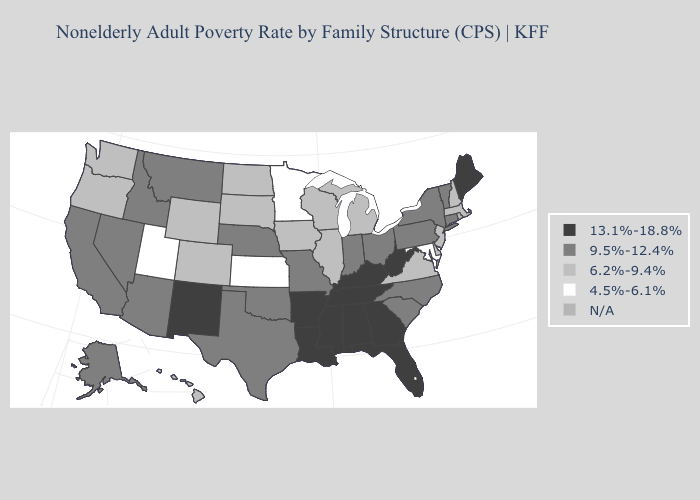Among the states that border Wisconsin , which have the lowest value?
Write a very short answer. Minnesota. Name the states that have a value in the range 13.1%-18.8%?
Answer briefly. Alabama, Arkansas, Florida, Georgia, Kentucky, Louisiana, Maine, Mississippi, New Mexico, Tennessee, West Virginia. Among the states that border Nevada , does California have the lowest value?
Keep it brief. No. Which states have the lowest value in the USA?
Concise answer only. Kansas, Maryland, Minnesota, Utah. Does Pennsylvania have the lowest value in the Northeast?
Concise answer only. No. Among the states that border Colorado , does New Mexico have the highest value?
Short answer required. Yes. What is the lowest value in the USA?
Give a very brief answer. 4.5%-6.1%. Among the states that border Illinois , does Wisconsin have the lowest value?
Keep it brief. Yes. Which states have the lowest value in the MidWest?
Write a very short answer. Kansas, Minnesota. Among the states that border Georgia , does Florida have the highest value?
Keep it brief. Yes. What is the highest value in the USA?
Keep it brief. 13.1%-18.8%. What is the highest value in the USA?
Answer briefly. 13.1%-18.8%. What is the highest value in the South ?
Concise answer only. 13.1%-18.8%. 